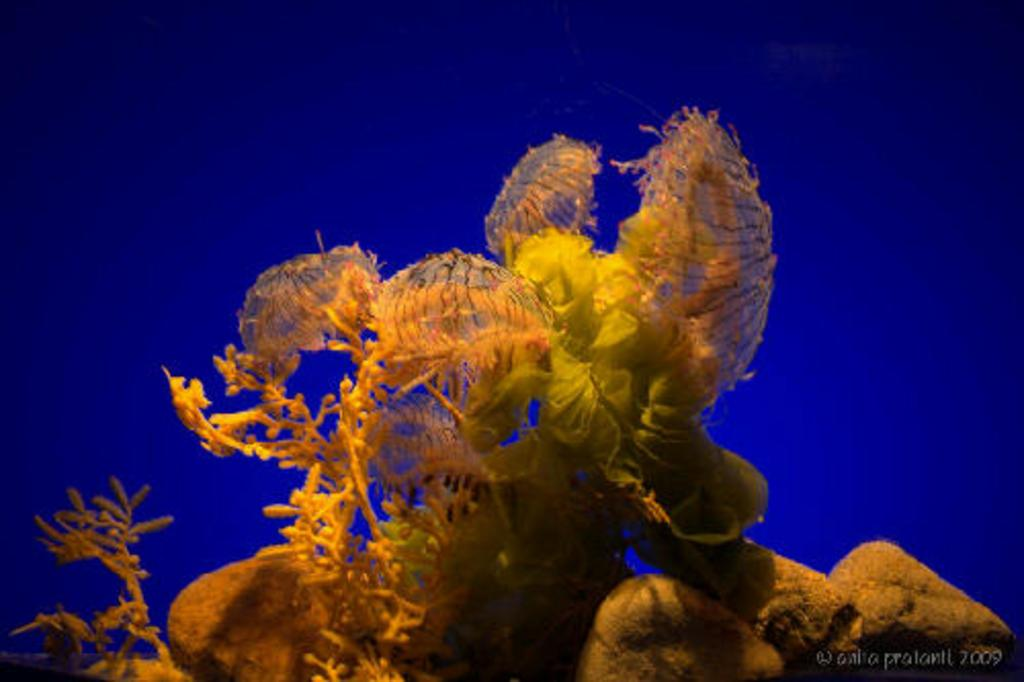What type of plants are visible in the image? There are aquatic plants in the image. What other objects can be seen in the image? There are stones visible in the image. What color is the background of the image? The background of the image is blue. Where is the text located in the image? The text is in the bottom right corner of the image. What type of linen is draped over the aquatic plants in the image? There is no linen present in the image; it features aquatic plants and stones with a blue background. 